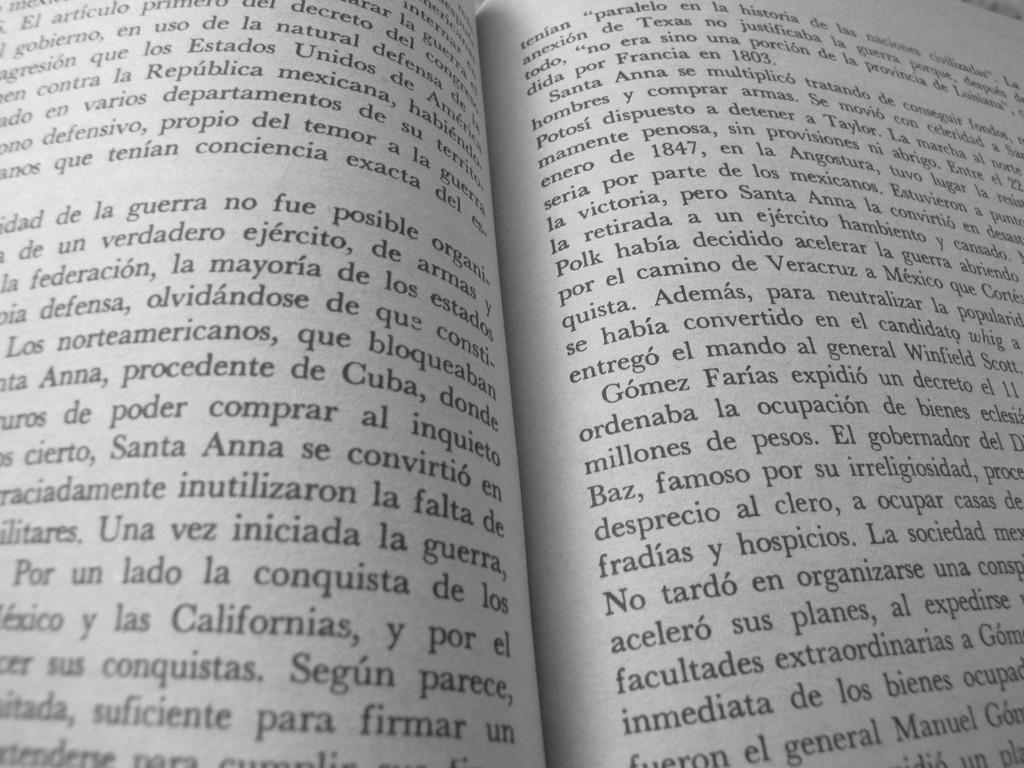What state is listed on the page on the left?
Your answer should be very brief. California. What date is listed on the right?
Your response must be concise. 1847. 